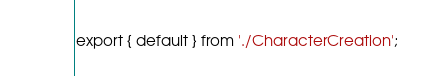<code> <loc_0><loc_0><loc_500><loc_500><_JavaScript_>export { default } from './CharacterCreation';
</code> 